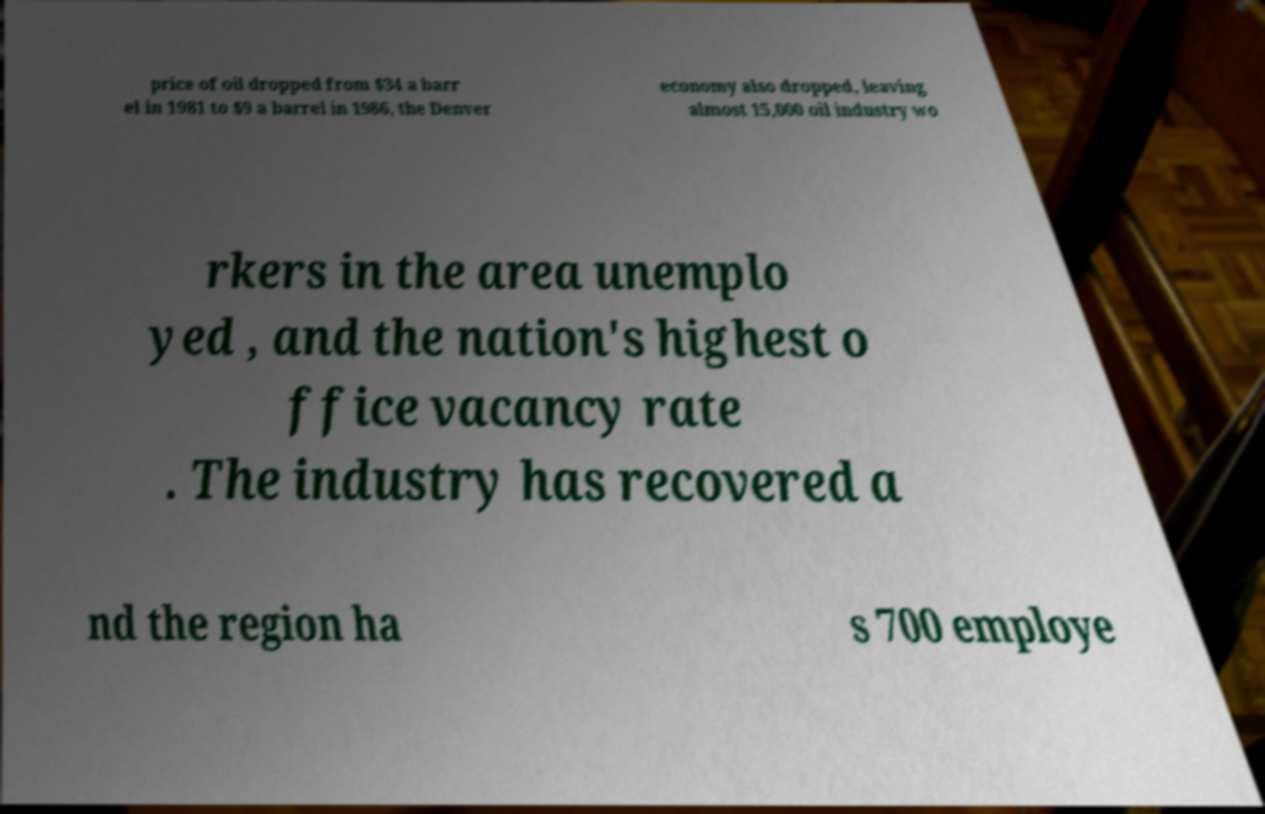There's text embedded in this image that I need extracted. Can you transcribe it verbatim? price of oil dropped from $34 a barr el in 1981 to $9 a barrel in 1986, the Denver economy also dropped, leaving almost 15,000 oil industry wo rkers in the area unemplo yed , and the nation's highest o ffice vacancy rate . The industry has recovered a nd the region ha s 700 employe 